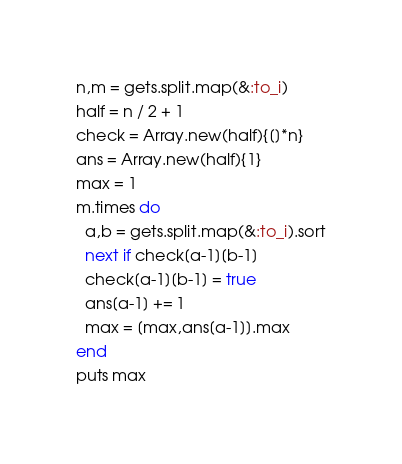Convert code to text. <code><loc_0><loc_0><loc_500><loc_500><_Ruby_>n,m = gets.split.map(&:to_i)
half = n / 2 + 1
check = Array.new(half){[]*n}
ans = Array.new(half){1}
max = 1
m.times do
  a,b = gets.split.map(&:to_i).sort
  next if check[a-1][b-1]
  check[a-1][b-1] = true
  ans[a-1] += 1
  max = [max,ans[a-1]].max
end
puts max
</code> 